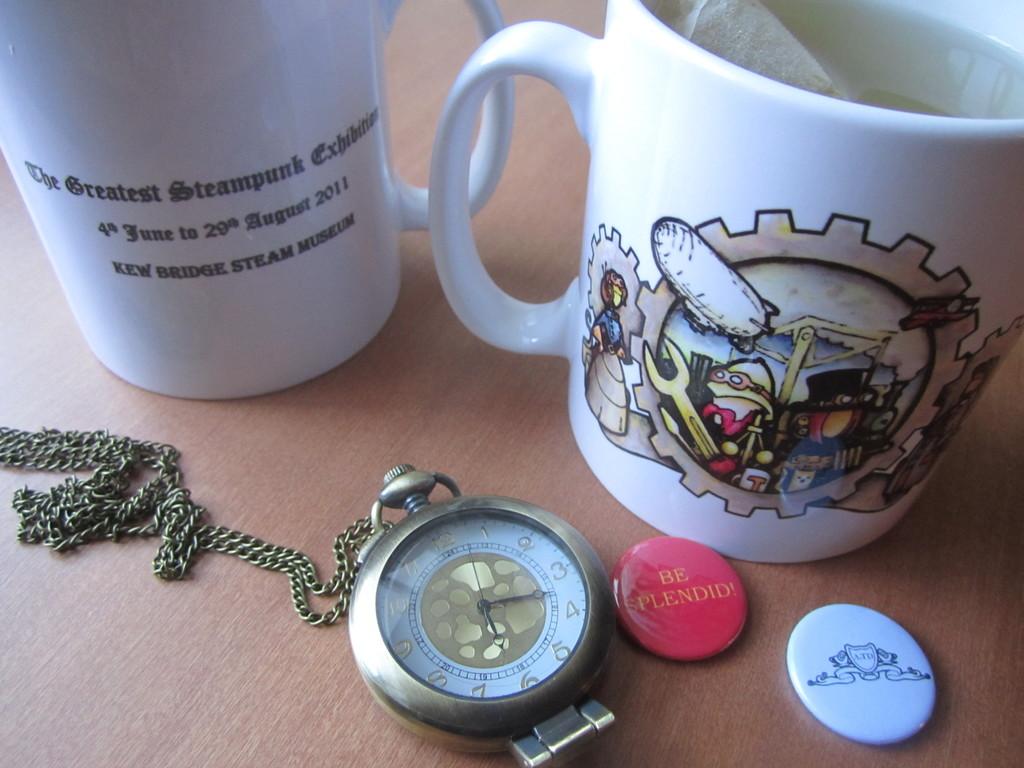The red button says be?
Your answer should be very brief. Splendid. What time is it?
Give a very brief answer. 6:17. 